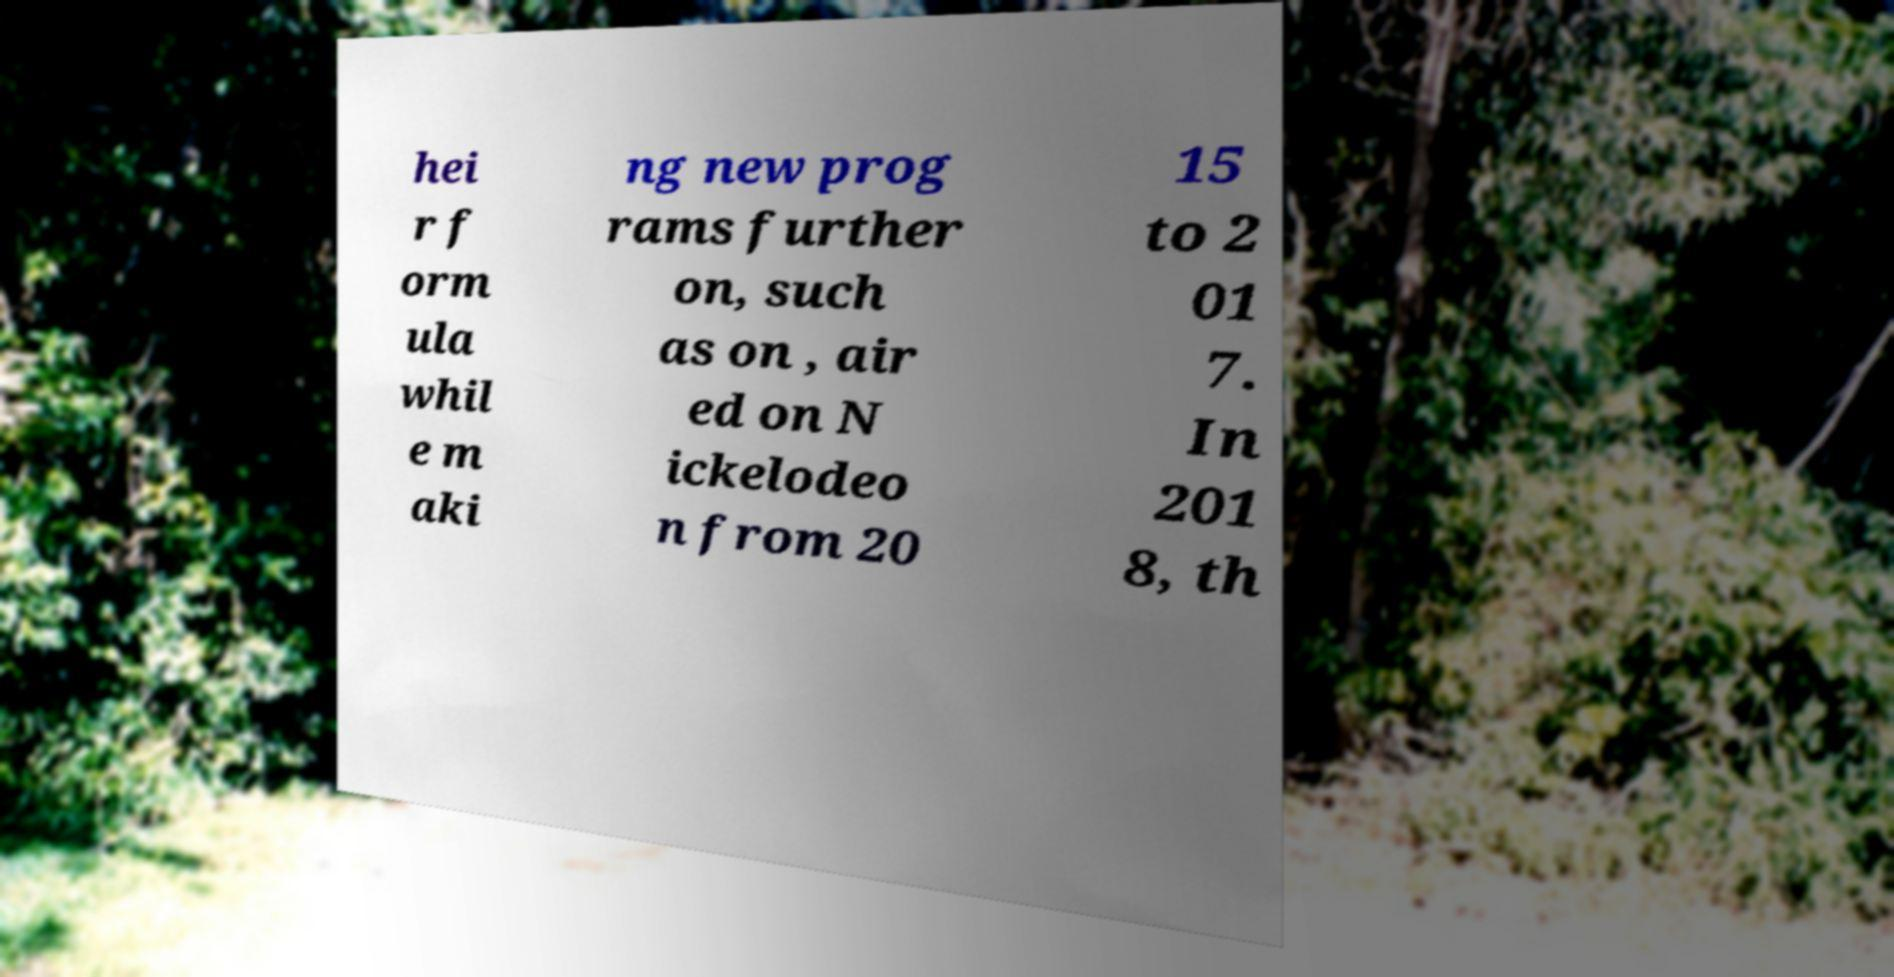Could you extract and type out the text from this image? hei r f orm ula whil e m aki ng new prog rams further on, such as on , air ed on N ickelodeo n from 20 15 to 2 01 7. In 201 8, th 